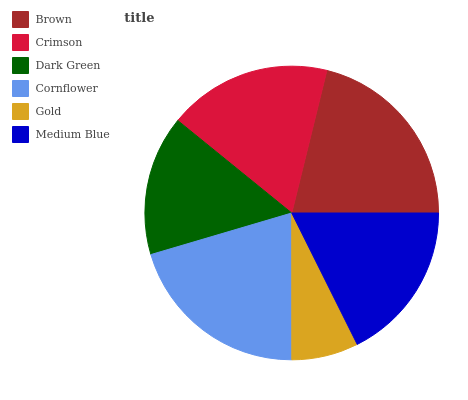Is Gold the minimum?
Answer yes or no. Yes. Is Brown the maximum?
Answer yes or no. Yes. Is Crimson the minimum?
Answer yes or no. No. Is Crimson the maximum?
Answer yes or no. No. Is Brown greater than Crimson?
Answer yes or no. Yes. Is Crimson less than Brown?
Answer yes or no. Yes. Is Crimson greater than Brown?
Answer yes or no. No. Is Brown less than Crimson?
Answer yes or no. No. Is Crimson the high median?
Answer yes or no. Yes. Is Medium Blue the low median?
Answer yes or no. Yes. Is Cornflower the high median?
Answer yes or no. No. Is Crimson the low median?
Answer yes or no. No. 